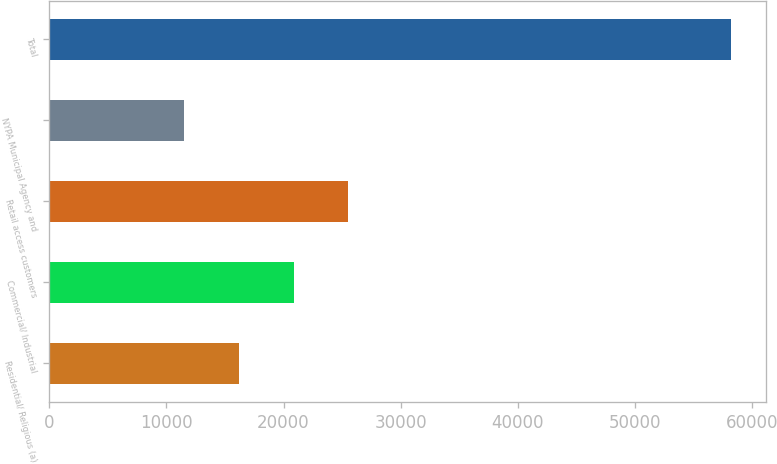<chart> <loc_0><loc_0><loc_500><loc_500><bar_chart><fcel>Residential/ Religious (a)<fcel>Commercial/ Industrial<fcel>Retail access customers<fcel>NYPA Municipal Agency and<fcel>Total<nl><fcel>16175.2<fcel>20851.4<fcel>25527.6<fcel>11499<fcel>58261<nl></chart> 